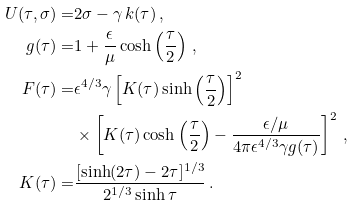Convert formula to latex. <formula><loc_0><loc_0><loc_500><loc_500>U ( \tau , \sigma ) = & 2 \sigma - \gamma \, k ( \tau ) \, , \\ g ( \tau ) = & 1 + \frac { \epsilon } { \mu } \cosh \left ( \frac { \tau } { 2 } \right ) \, , \\ F ( \tau ) = & \epsilon ^ { 4 / 3 } \gamma \left [ K ( \tau ) \sinh \left ( \frac { \tau } { 2 } \right ) \right ] ^ { 2 } \\ & \times \left [ K ( \tau ) \cosh \left ( \frac { \tau } { 2 } \right ) - \frac { \epsilon / \mu } { 4 \pi \epsilon ^ { 4 / 3 } \gamma g ( \tau ) } \right ] ^ { 2 } \, , \\ K ( \tau ) = & \frac { [ \sinh ( 2 \tau ) - 2 \tau ] ^ { 1 / 3 } } { 2 ^ { 1 / 3 } \sinh \tau } \, .</formula> 